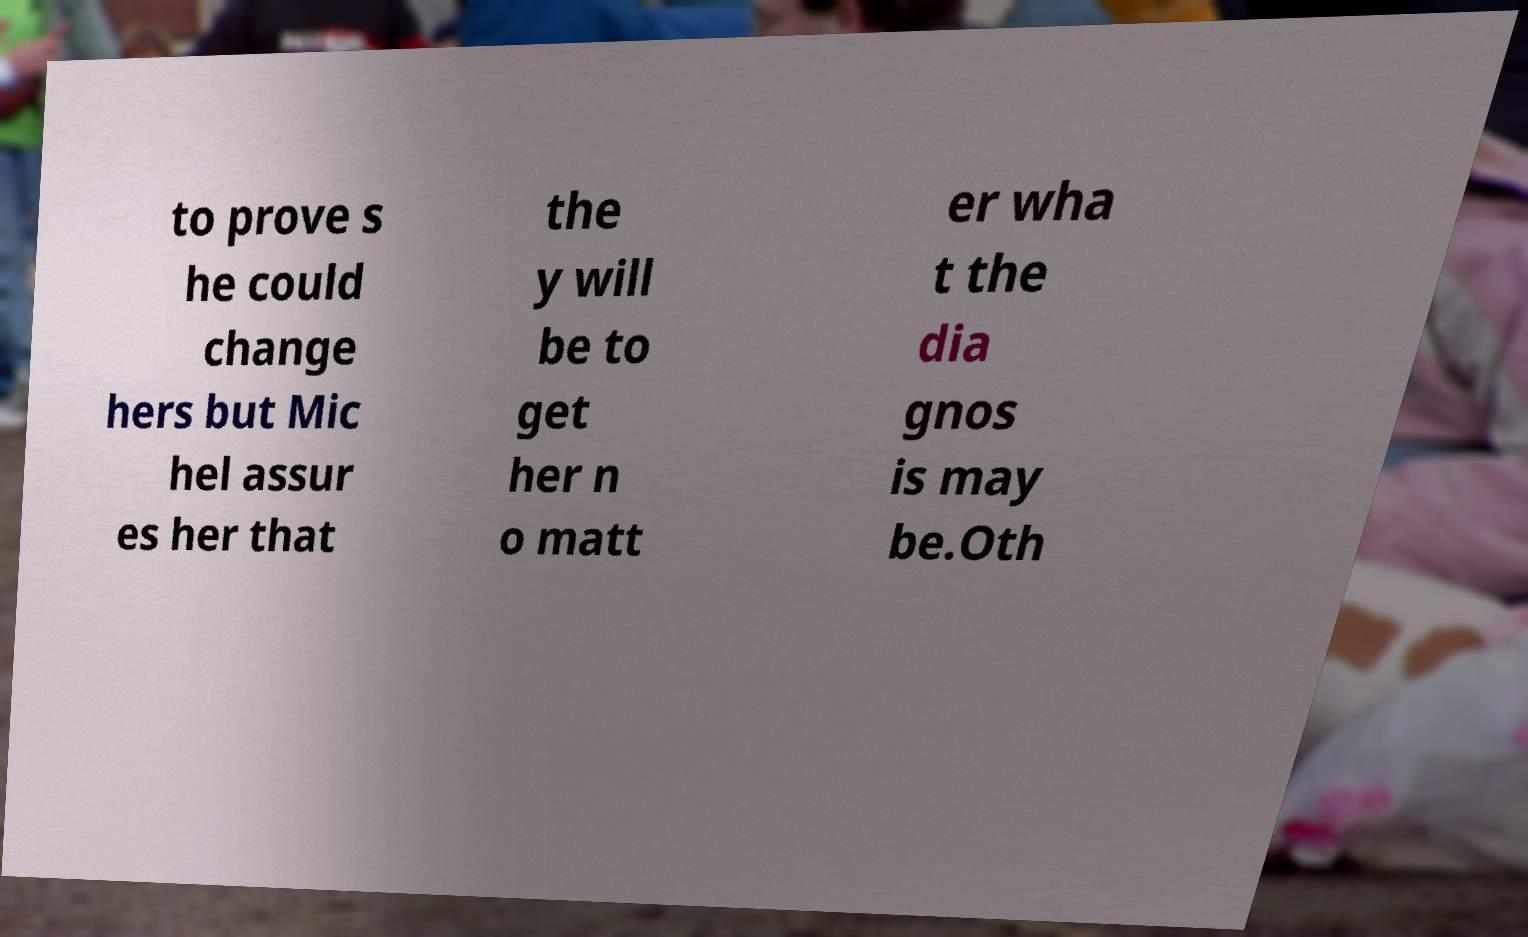Please identify and transcribe the text found in this image. to prove s he could change hers but Mic hel assur es her that the y will be to get her n o matt er wha t the dia gnos is may be.Oth 